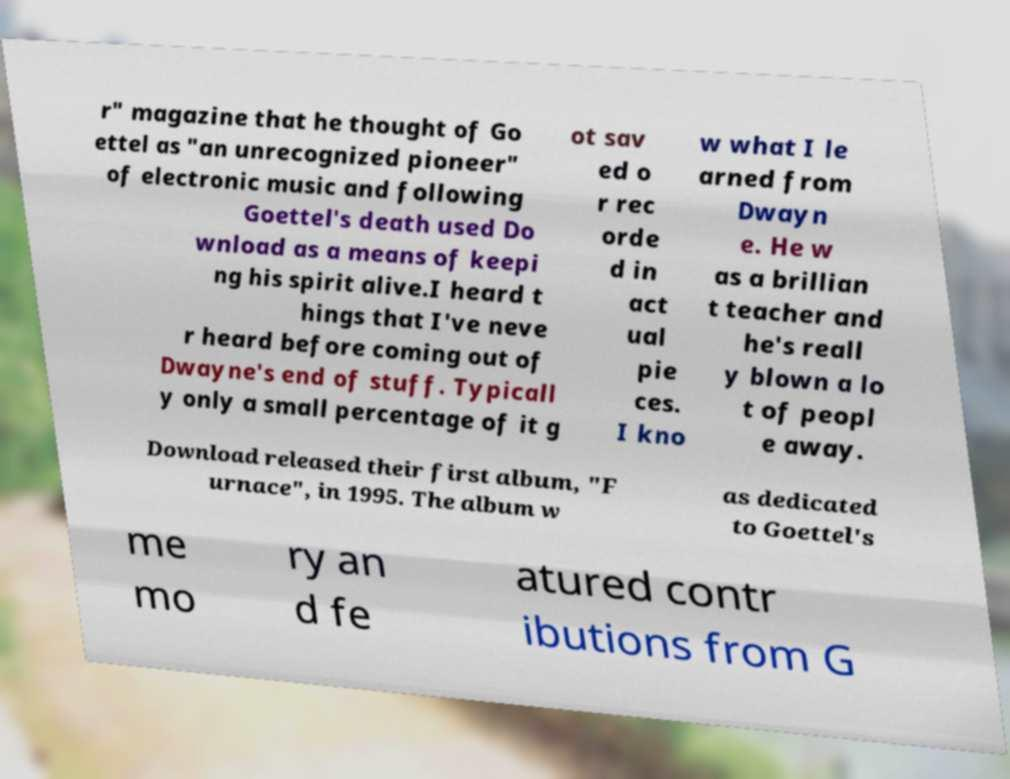Please read and relay the text visible in this image. What does it say? r" magazine that he thought of Go ettel as "an unrecognized pioneer" of electronic music and following Goettel's death used Do wnload as a means of keepi ng his spirit alive.I heard t hings that I've neve r heard before coming out of Dwayne's end of stuff. Typicall y only a small percentage of it g ot sav ed o r rec orde d in act ual pie ces. I kno w what I le arned from Dwayn e. He w as a brillian t teacher and he's reall y blown a lo t of peopl e away. Download released their first album, "F urnace", in 1995. The album w as dedicated to Goettel's me mo ry an d fe atured contr ibutions from G 